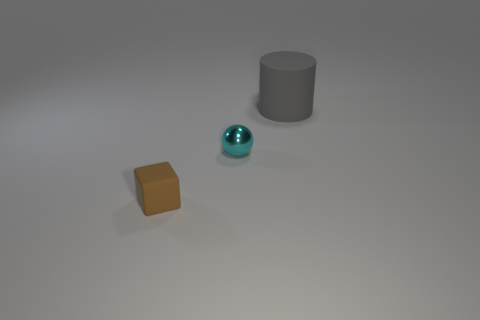How are the shapes of the objects significant in this arrangement? The arrangement includes a cylinder, a sphere, and a cube which are fundamental geometric shapes. This could represent an interest in geometric diversity, an experiment with forms, or an artistic display highlighting the contrast between shapes in space. 